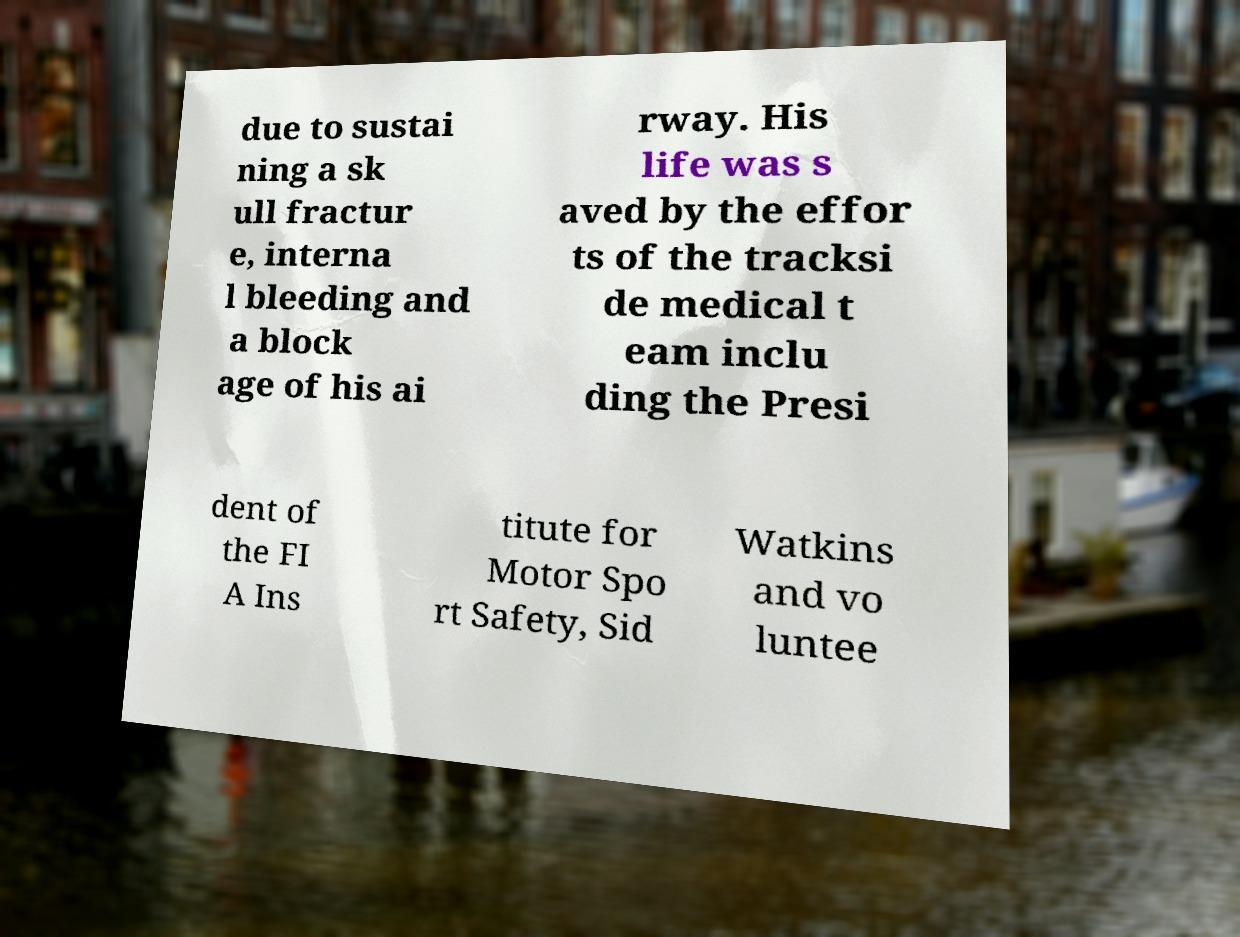What messages or text are displayed in this image? I need them in a readable, typed format. due to sustai ning a sk ull fractur e, interna l bleeding and a block age of his ai rway. His life was s aved by the effor ts of the tracksi de medical t eam inclu ding the Presi dent of the FI A Ins titute for Motor Spo rt Safety, Sid Watkins and vo luntee 